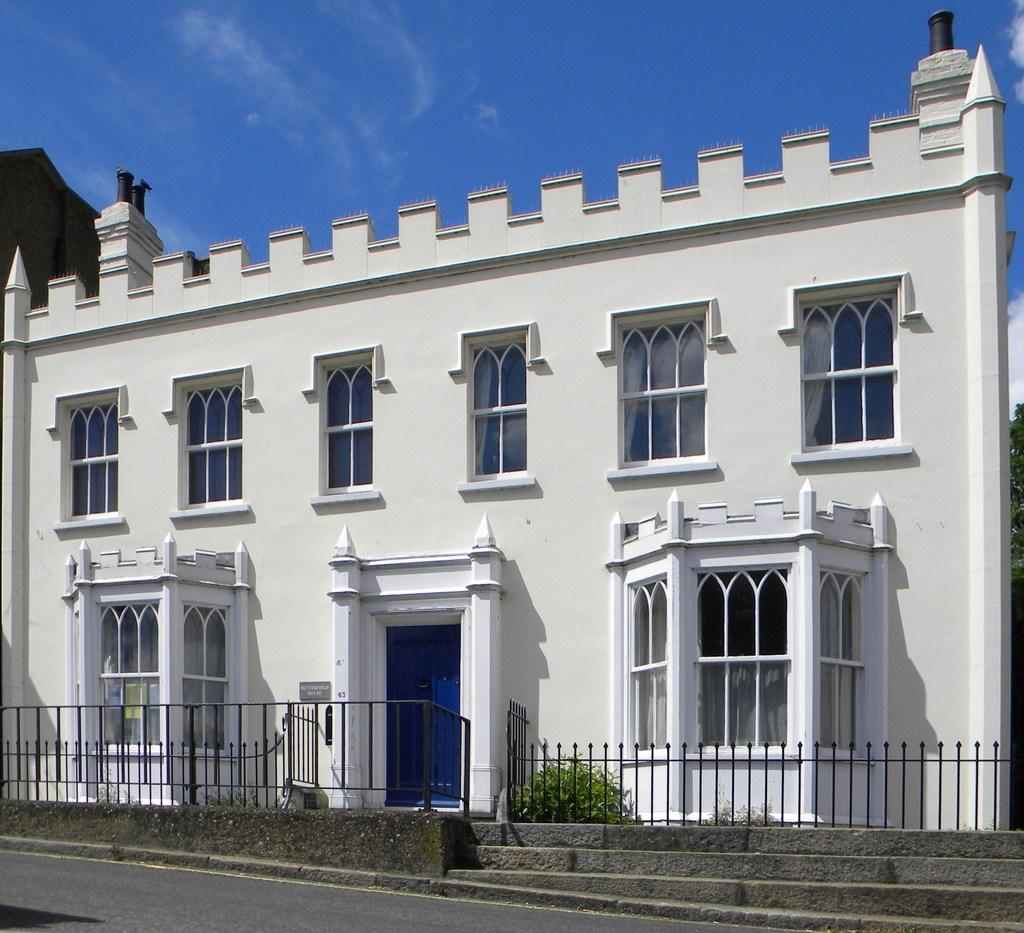What structure is visible in the image? There is a building in the image. What is located in front of the building? There is a plant in front of the building. What is in front of the plant? There is a railing in front of the plant. What is in front of the railing? There is a road in front of the railing. What can be seen in the background of the image? The sky is visible in the background of the image. What is the profit margin of the plant in the image? There is no information about profit margins in the image, as it features a building, plant, railing, road, and sky. How many steps are required to reach the top of the plant in the image? The plant in the image is not a staircase or a structure with steps; it is a plant. 